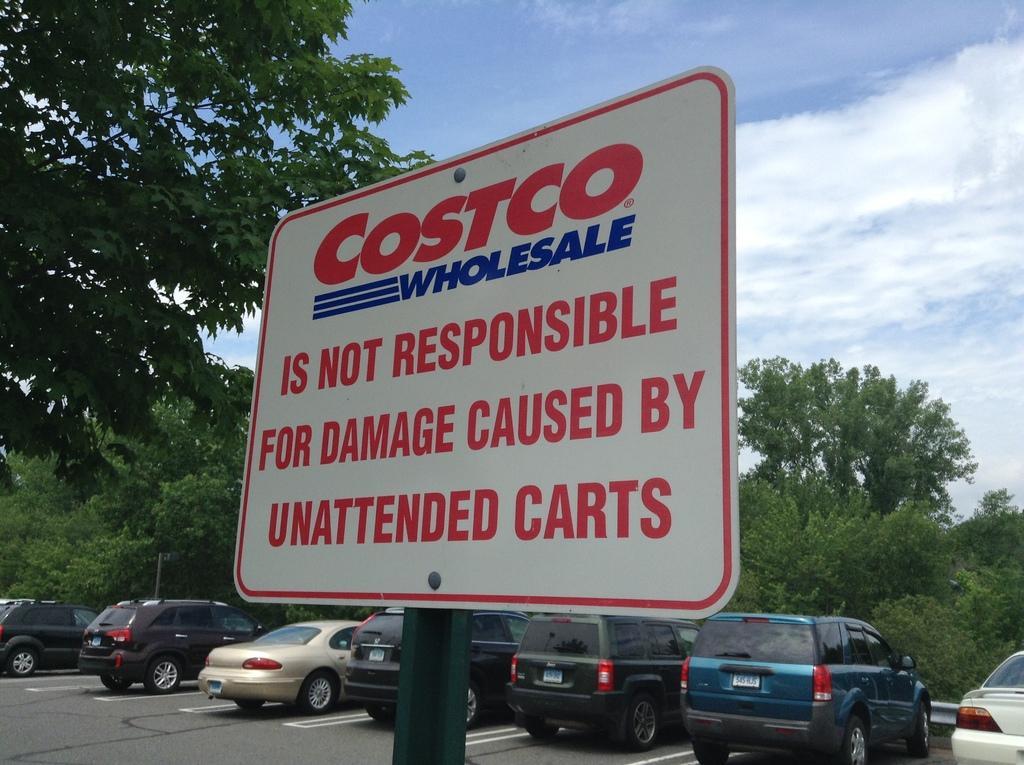Could you give a brief overview of what you see in this image? In this picture I can see there is a precaution board and it has something written on it. There are few cars parked in the backdrop and there are trees and the sky is clear. 